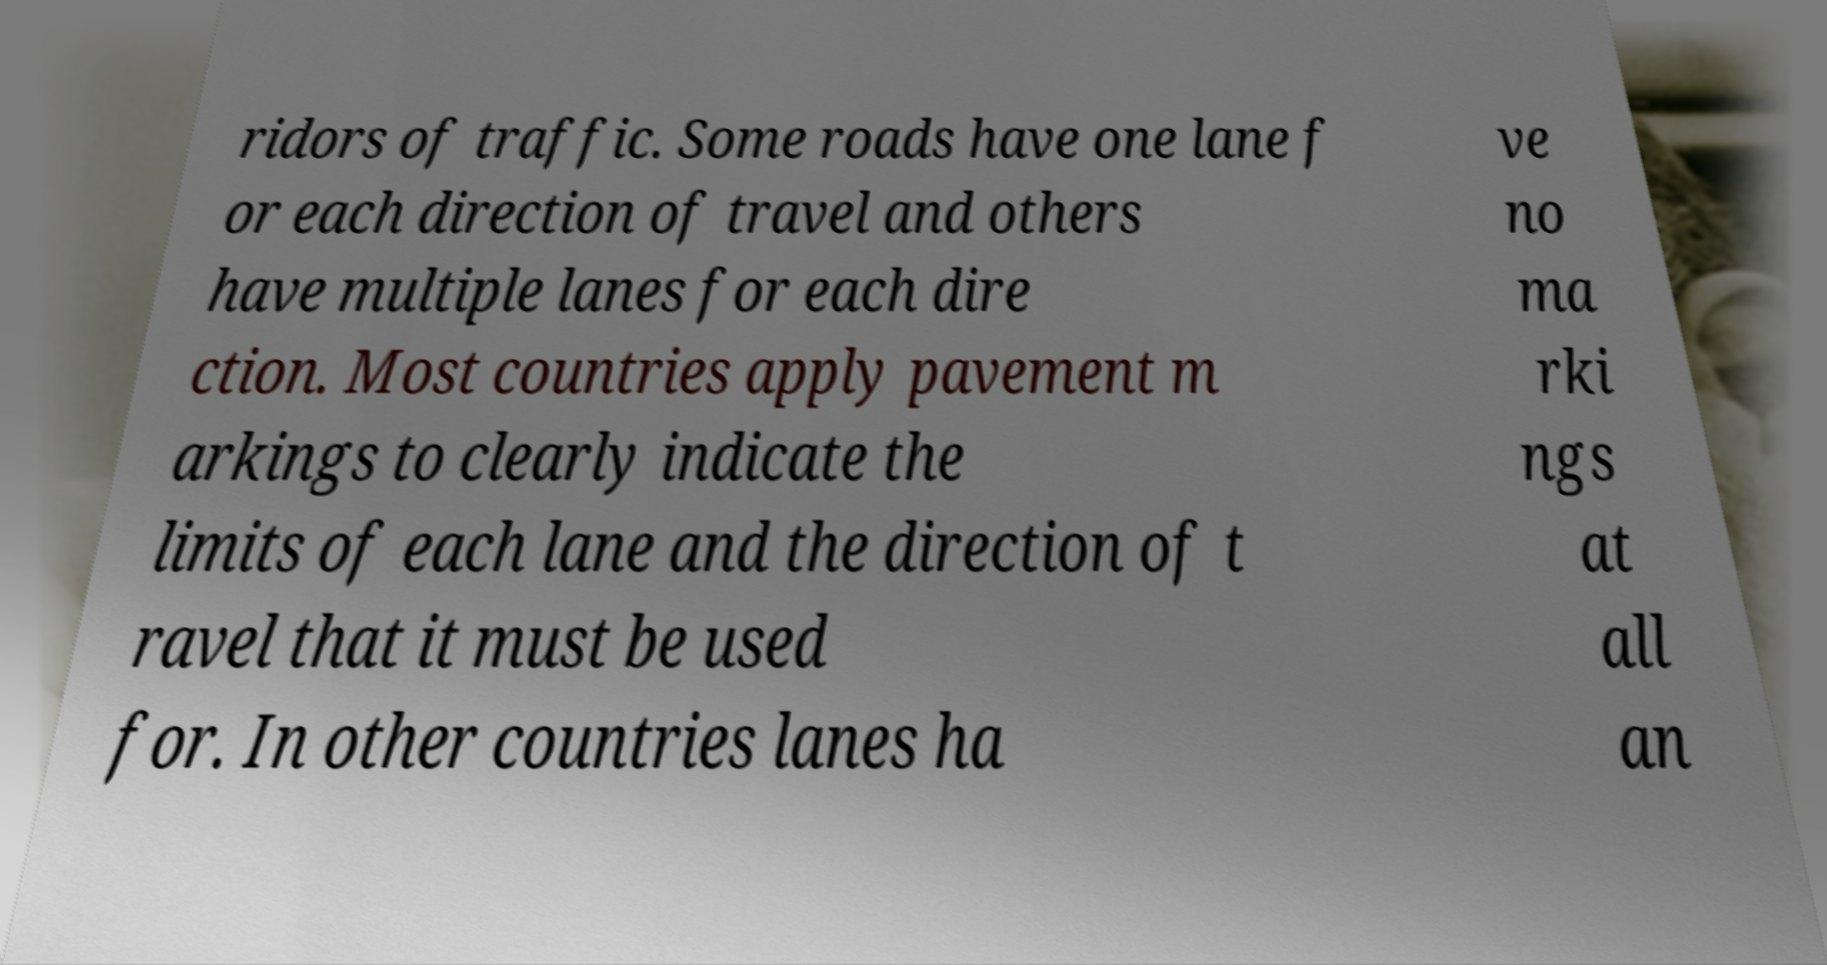For documentation purposes, I need the text within this image transcribed. Could you provide that? ridors of traffic. Some roads have one lane f or each direction of travel and others have multiple lanes for each dire ction. Most countries apply pavement m arkings to clearly indicate the limits of each lane and the direction of t ravel that it must be used for. In other countries lanes ha ve no ma rki ngs at all an 